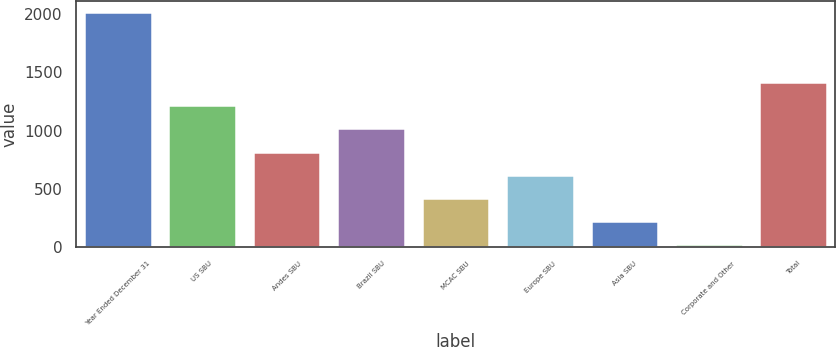Convert chart. <chart><loc_0><loc_0><loc_500><loc_500><bar_chart><fcel>Year Ended December 31<fcel>US SBU<fcel>Andes SBU<fcel>Brazil SBU<fcel>MCAC SBU<fcel>Europe SBU<fcel>Asia SBU<fcel>Corporate and Other<fcel>Total<nl><fcel>2014<fcel>1218<fcel>820<fcel>1019<fcel>422<fcel>621<fcel>223<fcel>24<fcel>1417<nl></chart> 